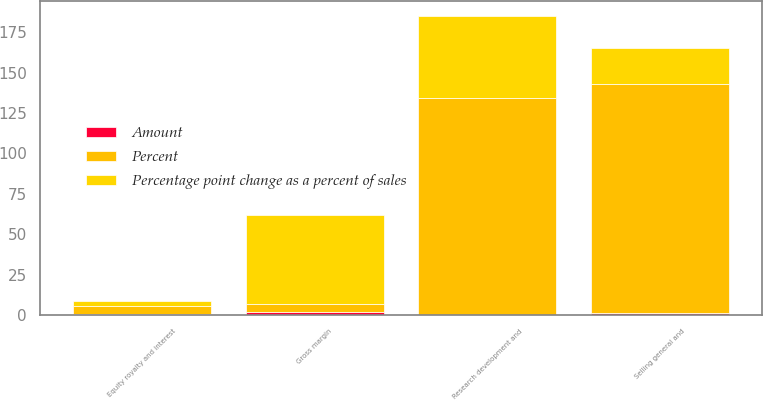Convert chart. <chart><loc_0><loc_0><loc_500><loc_500><stacked_bar_chart><ecel><fcel>Gross margin<fcel>Selling general and<fcel>Research development and<fcel>Equity royalty and interest<nl><fcel>Percent<fcel>5<fcel>142<fcel>134<fcel>5<nl><fcel>Percentage point change as a percent of sales<fcel>55<fcel>22<fcel>51<fcel>3<nl><fcel>Amount<fcel>1.7<fcel>1.2<fcel>0.2<fcel>0.5<nl></chart> 